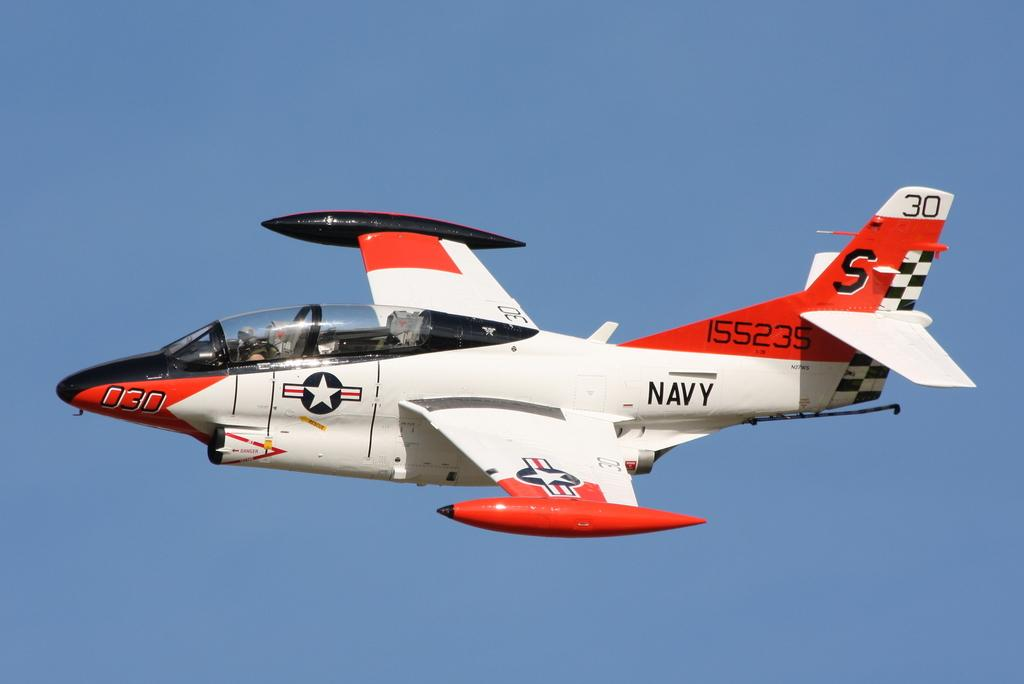<image>
Create a compact narrative representing the image presented. a white red and black NAVY plane in the sky 